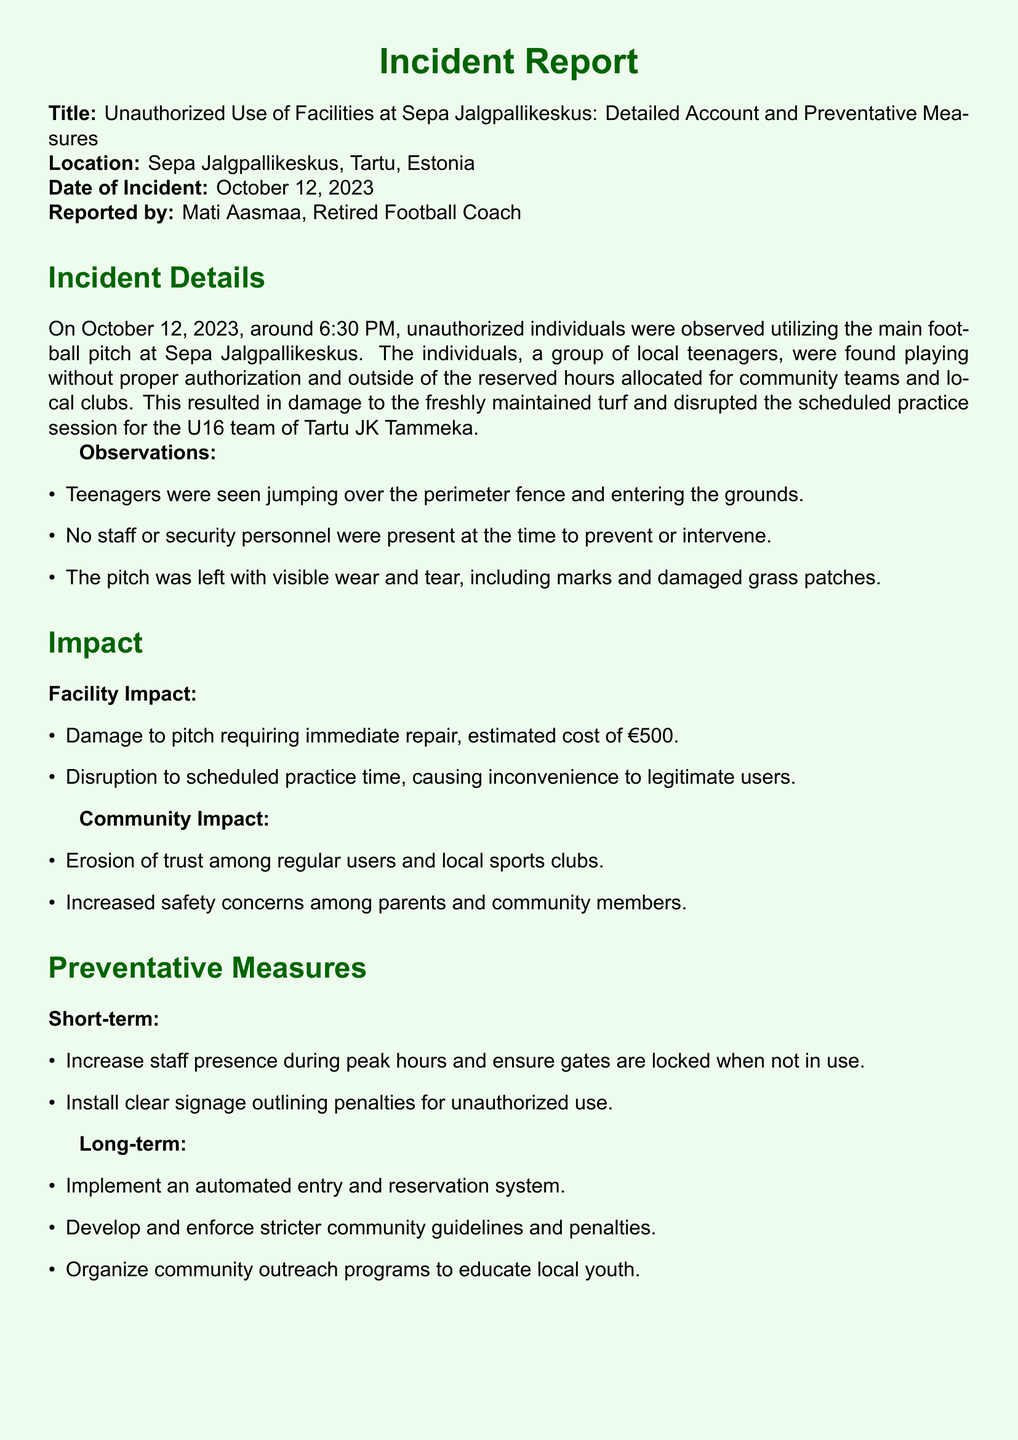What date did the incident occur? The date of the incident is clearly noted in the report as October 12, 2023.
Answer: October 12, 2023 Who reported the incident? The report specifies that Mati Aasmaa, a retired football coach, is the one who reported the incident.
Answer: Mati Aasmaa What was the estimated cost of the damage? The document states that the estimated cost to repair the damage to the pitch is €500.
Answer: €500 What was the age group of the affected team? The report mentions that the U16 team of Tartu JK Tammeka was disrupted during their scheduled practice.
Answer: U16 What measure is suggested to increase security in the short term? The report suggests increasing staff presence during peak hours as a short-term measure to prevent unauthorized use.
Answer: Increase staff presence Why is community trust described as being eroded? The report indicates that the unauthorized use of facilities leads to a loss of trust among regular users and local sports clubs.
Answer: Erosion of trust What automated system is recommended in the long term? The report recommends implementing an automated entry and reservation system as part of the long-term preventative measures.
Answer: Automated entry and reservation system What signage is proposed to address unauthorized use? The document advises installing clear signage outlining penalties for unauthorized use in the short-term preventative measures.
Answer: Clear signage What group was seen entering the facility without permission? The report identifies a group of local teenagers as the unauthorized individuals who accessed the facility.
Answer: Local teenagers 